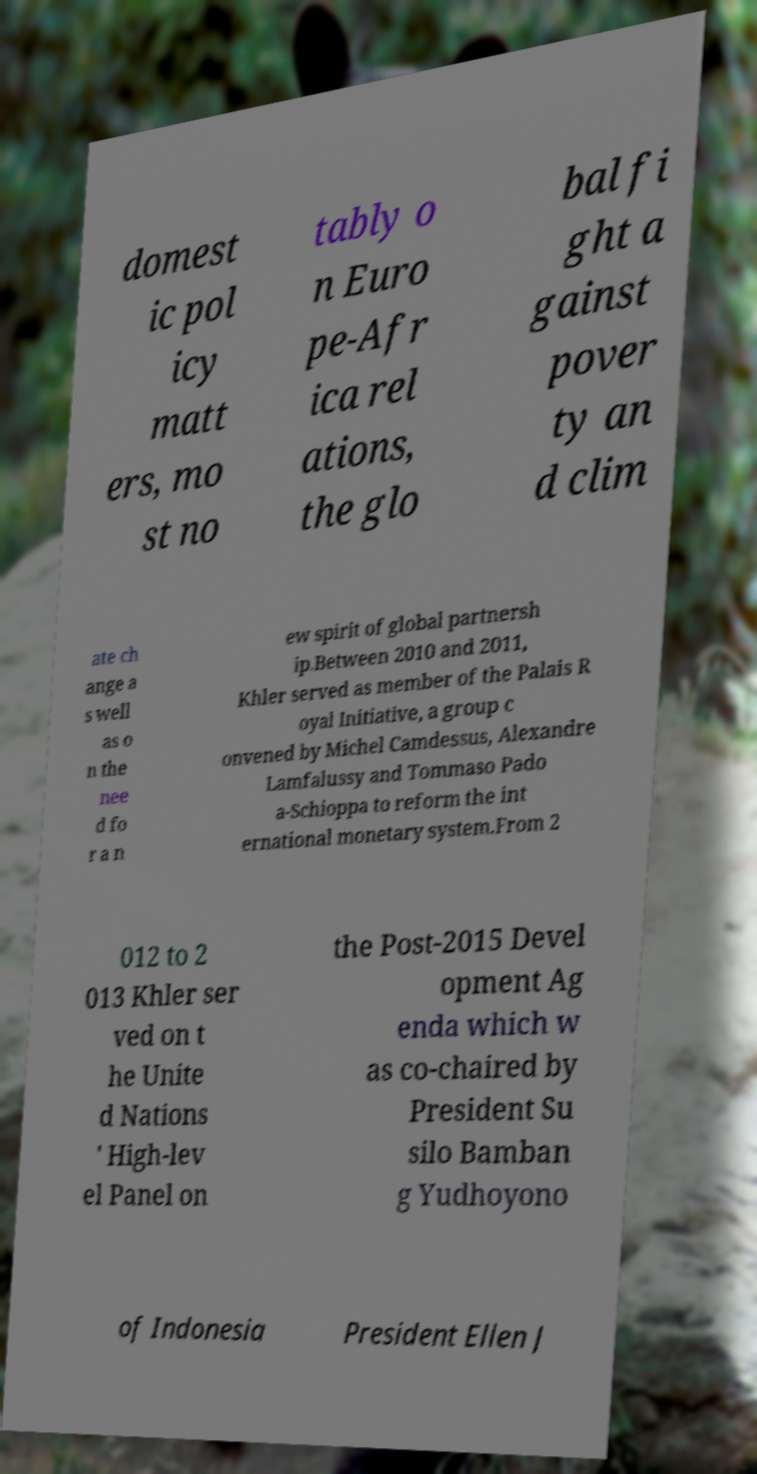There's text embedded in this image that I need extracted. Can you transcribe it verbatim? domest ic pol icy matt ers, mo st no tably o n Euro pe-Afr ica rel ations, the glo bal fi ght a gainst pover ty an d clim ate ch ange a s well as o n the nee d fo r a n ew spirit of global partnersh ip.Between 2010 and 2011, Khler served as member of the Palais R oyal Initiative, a group c onvened by Michel Camdessus, Alexandre Lamfalussy and Tommaso Pado a-Schioppa to reform the int ernational monetary system.From 2 012 to 2 013 Khler ser ved on t he Unite d Nations ' High-lev el Panel on the Post-2015 Devel opment Ag enda which w as co-chaired by President Su silo Bamban g Yudhoyono of Indonesia President Ellen J 